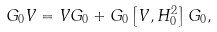Convert formula to latex. <formula><loc_0><loc_0><loc_500><loc_500>G _ { 0 } V = V G _ { 0 } + G _ { 0 } \left [ V , H _ { 0 } ^ { 2 } \right ] G _ { 0 } ,</formula> 